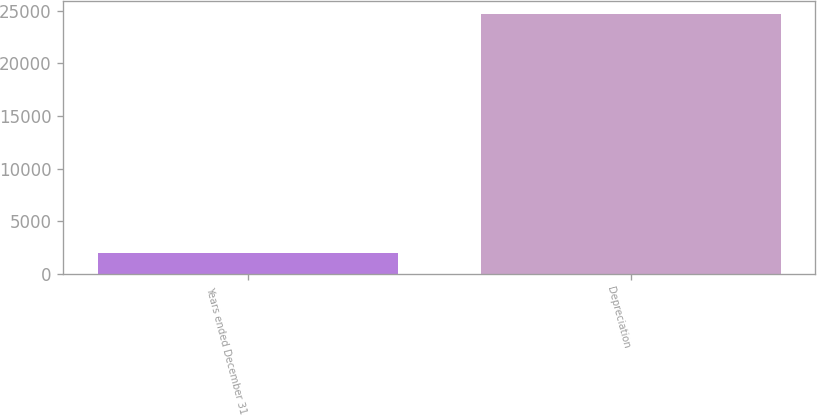<chart> <loc_0><loc_0><loc_500><loc_500><bar_chart><fcel>Years ended December 31<fcel>Depreciation<nl><fcel>2016<fcel>24725<nl></chart> 